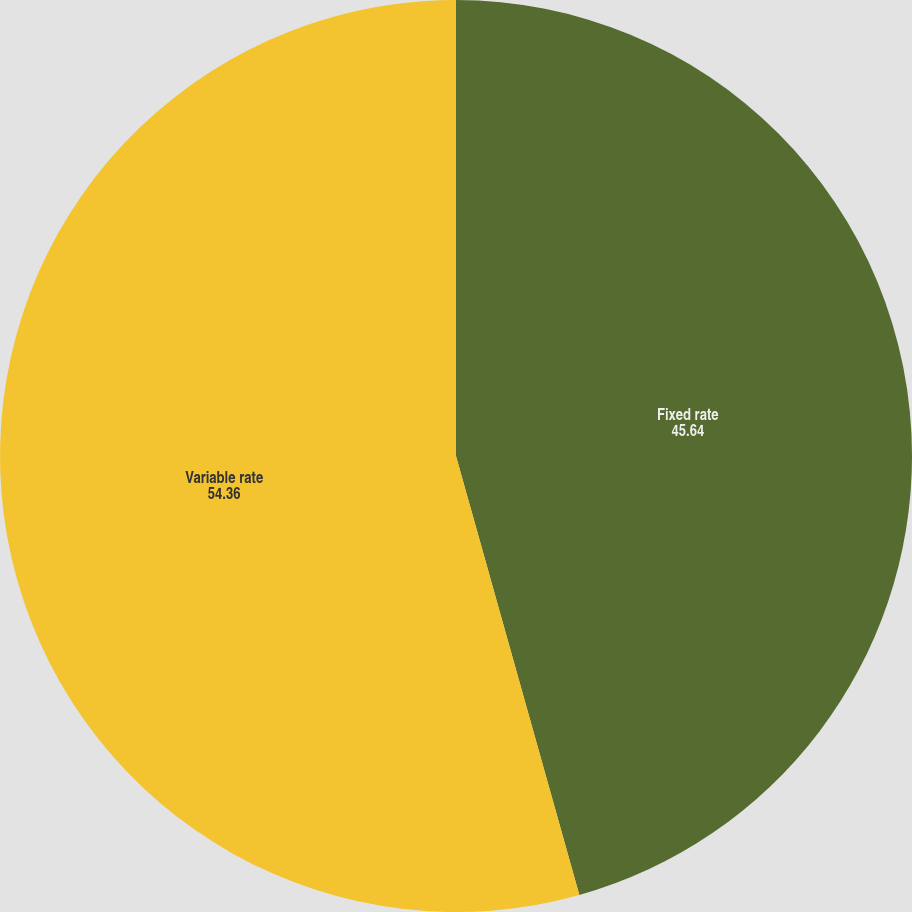Convert chart to OTSL. <chart><loc_0><loc_0><loc_500><loc_500><pie_chart><fcel>Fixed rate<fcel>Variable rate<nl><fcel>45.64%<fcel>54.36%<nl></chart> 